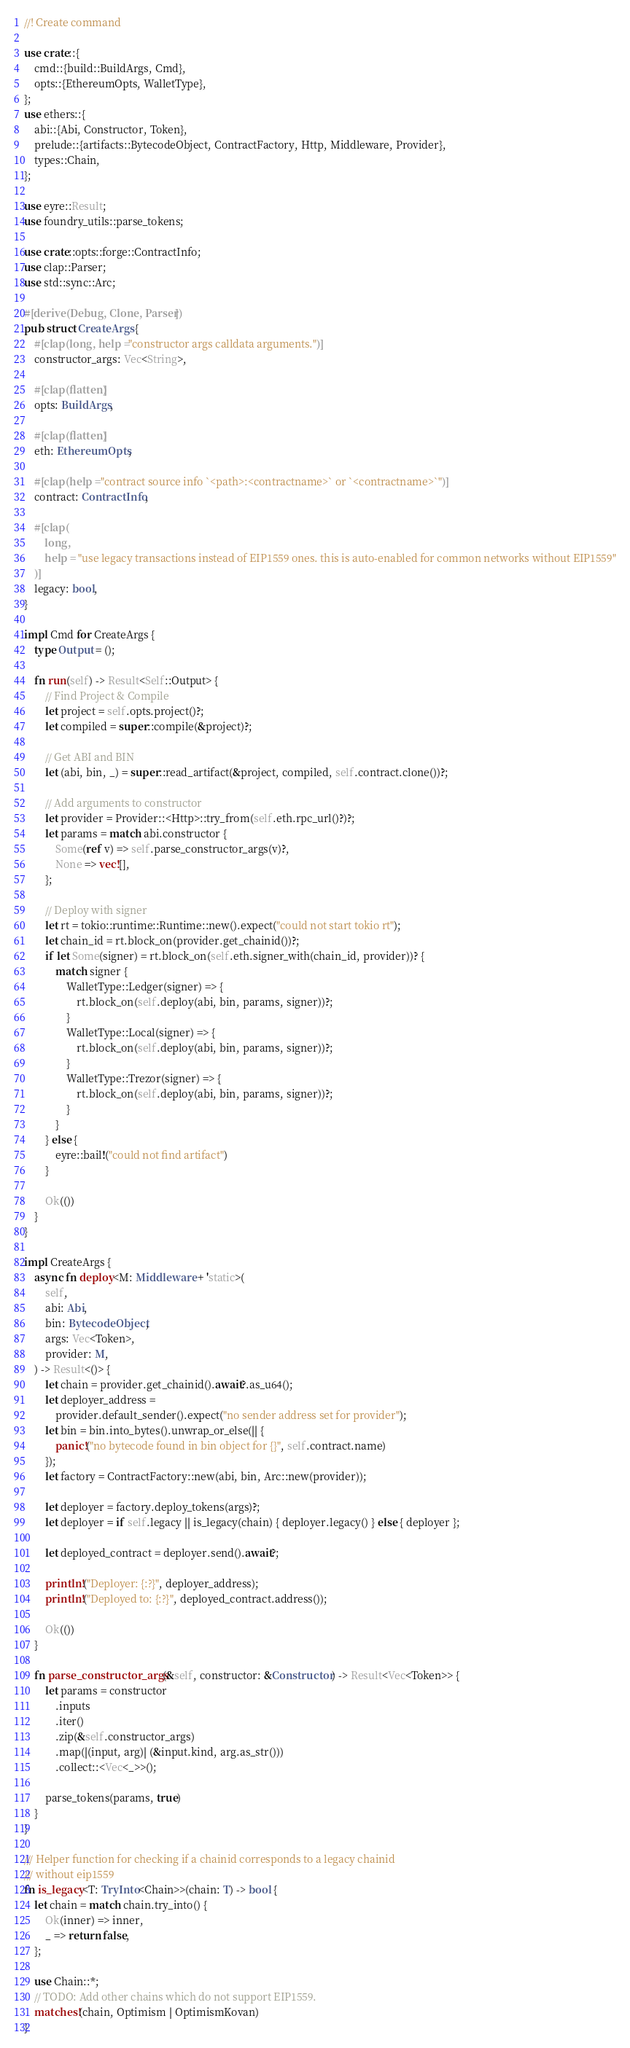Convert code to text. <code><loc_0><loc_0><loc_500><loc_500><_Rust_>//! Create command

use crate::{
    cmd::{build::BuildArgs, Cmd},
    opts::{EthereumOpts, WalletType},
};
use ethers::{
    abi::{Abi, Constructor, Token},
    prelude::{artifacts::BytecodeObject, ContractFactory, Http, Middleware, Provider},
    types::Chain,
};

use eyre::Result;
use foundry_utils::parse_tokens;

use crate::opts::forge::ContractInfo;
use clap::Parser;
use std::sync::Arc;

#[derive(Debug, Clone, Parser)]
pub struct CreateArgs {
    #[clap(long, help = "constructor args calldata arguments.")]
    constructor_args: Vec<String>,

    #[clap(flatten)]
    opts: BuildArgs,

    #[clap(flatten)]
    eth: EthereumOpts,

    #[clap(help = "contract source info `<path>:<contractname>` or `<contractname>`")]
    contract: ContractInfo,

    #[clap(
        long,
        help = "use legacy transactions instead of EIP1559 ones. this is auto-enabled for common networks without EIP1559"
    )]
    legacy: bool,
}

impl Cmd for CreateArgs {
    type Output = ();

    fn run(self) -> Result<Self::Output> {
        // Find Project & Compile
        let project = self.opts.project()?;
        let compiled = super::compile(&project)?;

        // Get ABI and BIN
        let (abi, bin, _) = super::read_artifact(&project, compiled, self.contract.clone())?;

        // Add arguments to constructor
        let provider = Provider::<Http>::try_from(self.eth.rpc_url()?)?;
        let params = match abi.constructor {
            Some(ref v) => self.parse_constructor_args(v)?,
            None => vec![],
        };

        // Deploy with signer
        let rt = tokio::runtime::Runtime::new().expect("could not start tokio rt");
        let chain_id = rt.block_on(provider.get_chainid())?;
        if let Some(signer) = rt.block_on(self.eth.signer_with(chain_id, provider))? {
            match signer {
                WalletType::Ledger(signer) => {
                    rt.block_on(self.deploy(abi, bin, params, signer))?;
                }
                WalletType::Local(signer) => {
                    rt.block_on(self.deploy(abi, bin, params, signer))?;
                }
                WalletType::Trezor(signer) => {
                    rt.block_on(self.deploy(abi, bin, params, signer))?;
                }
            }
        } else {
            eyre::bail!("could not find artifact")
        }

        Ok(())
    }
}

impl CreateArgs {
    async fn deploy<M: Middleware + 'static>(
        self,
        abi: Abi,
        bin: BytecodeObject,
        args: Vec<Token>,
        provider: M,
    ) -> Result<()> {
        let chain = provider.get_chainid().await?.as_u64();
        let deployer_address =
            provider.default_sender().expect("no sender address set for provider");
        let bin = bin.into_bytes().unwrap_or_else(|| {
            panic!("no bytecode found in bin object for {}", self.contract.name)
        });
        let factory = ContractFactory::new(abi, bin, Arc::new(provider));

        let deployer = factory.deploy_tokens(args)?;
        let deployer = if self.legacy || is_legacy(chain) { deployer.legacy() } else { deployer };

        let deployed_contract = deployer.send().await?;

        println!("Deployer: {:?}", deployer_address);
        println!("Deployed to: {:?}", deployed_contract.address());

        Ok(())
    }

    fn parse_constructor_args(&self, constructor: &Constructor) -> Result<Vec<Token>> {
        let params = constructor
            .inputs
            .iter()
            .zip(&self.constructor_args)
            .map(|(input, arg)| (&input.kind, arg.as_str()))
            .collect::<Vec<_>>();

        parse_tokens(params, true)
    }
}

/// Helper function for checking if a chainid corresponds to a legacy chainid
/// without eip1559
fn is_legacy<T: TryInto<Chain>>(chain: T) -> bool {
    let chain = match chain.try_into() {
        Ok(inner) => inner,
        _ => return false,
    };

    use Chain::*;
    // TODO: Add other chains which do not support EIP1559.
    matches!(chain, Optimism | OptimismKovan)
}
</code> 